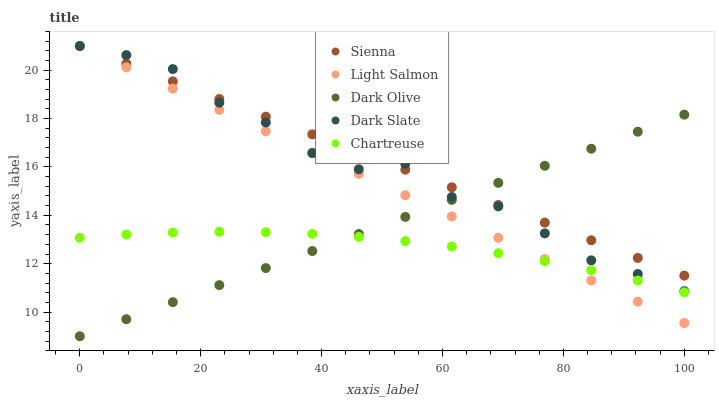Does Chartreuse have the minimum area under the curve?
Answer yes or no. Yes. Does Sienna have the maximum area under the curve?
Answer yes or no. Yes. Does Dark Slate have the minimum area under the curve?
Answer yes or no. No. Does Dark Slate have the maximum area under the curve?
Answer yes or no. No. Is Dark Olive the smoothest?
Answer yes or no. Yes. Is Dark Slate the roughest?
Answer yes or no. Yes. Is Light Salmon the smoothest?
Answer yes or no. No. Is Light Salmon the roughest?
Answer yes or no. No. Does Dark Olive have the lowest value?
Answer yes or no. Yes. Does Dark Slate have the lowest value?
Answer yes or no. No. Does Light Salmon have the highest value?
Answer yes or no. Yes. Does Dark Olive have the highest value?
Answer yes or no. No. Is Chartreuse less than Dark Slate?
Answer yes or no. Yes. Is Sienna greater than Chartreuse?
Answer yes or no. Yes. Does Dark Slate intersect Light Salmon?
Answer yes or no. Yes. Is Dark Slate less than Light Salmon?
Answer yes or no. No. Is Dark Slate greater than Light Salmon?
Answer yes or no. No. Does Chartreuse intersect Dark Slate?
Answer yes or no. No. 